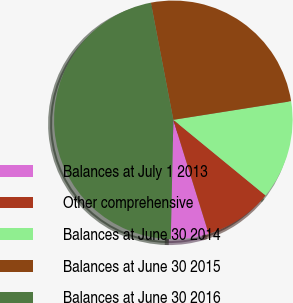Convert chart. <chart><loc_0><loc_0><loc_500><loc_500><pie_chart><fcel>Balances at July 1 2013<fcel>Other comprehensive<fcel>Balances at June 30 2014<fcel>Balances at June 30 2015<fcel>Balances at June 30 2016<nl><fcel>5.13%<fcel>9.28%<fcel>13.43%<fcel>25.52%<fcel>46.64%<nl></chart> 